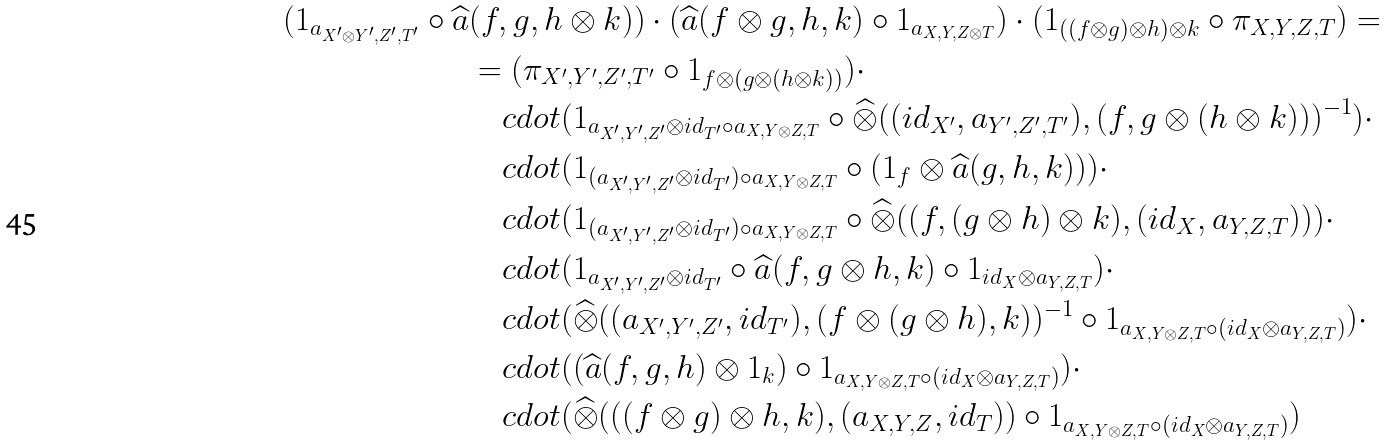<formula> <loc_0><loc_0><loc_500><loc_500>( 1 _ { a _ { X ^ { \prime } \otimes Y ^ { \prime } , Z ^ { \prime } , T ^ { \prime } } } \circ \widehat { a } & ( f , g , h \otimes k ) ) \cdot ( \widehat { a } ( f \otimes g , h , k ) \circ 1 _ { a _ { X , Y , Z \otimes T } } ) \cdot ( 1 _ { ( ( f \otimes g ) \otimes h ) \otimes k } \circ \pi _ { X , Y , Z , T } ) = \\ & = ( \pi _ { X ^ { \prime } , Y ^ { \prime } , Z ^ { \prime } , T ^ { \prime } } \circ 1 _ { f \otimes ( g \otimes ( h \otimes k ) ) } ) \cdot \\ & \quad c d o t ( 1 _ { a _ { X ^ { \prime } , Y ^ { \prime } , Z ^ { \prime } } \otimes i d _ { T ^ { \prime } } \circ a _ { X , Y \otimes Z , T } } \circ \widehat { \otimes } ( ( i d _ { X ^ { \prime } } , a _ { Y ^ { \prime } , Z ^ { \prime } , T ^ { \prime } } ) , ( f , g \otimes ( h \otimes k ) ) ) ^ { - 1 } ) \cdot \\ & \quad c d o t ( 1 _ { ( a _ { X ^ { \prime } , Y ^ { \prime } , Z ^ { \prime } } \otimes i d _ { T ^ { \prime } } ) \circ a _ { X , Y \otimes Z , T } } \circ ( 1 _ { f } \otimes \widehat { a } ( g , h , k ) ) ) \cdot \\ & \quad c d o t ( 1 _ { ( a _ { X ^ { \prime } , Y ^ { \prime } , Z ^ { \prime } } \otimes i d _ { T ^ { \prime } } ) \circ a _ { X , Y \otimes Z , T } } \circ \widehat { \otimes } ( ( f , ( g \otimes h ) \otimes k ) , ( i d _ { X } , a _ { Y , Z , T } ) ) ) \cdot \\ & \quad c d o t ( 1 _ { a _ { X ^ { \prime } , Y ^ { \prime } , Z ^ { \prime } } \otimes i d _ { T ^ { \prime } } } \circ \widehat { a } ( f , g \otimes h , k ) \circ 1 _ { i d _ { X } \otimes a _ { Y , Z , T } } ) \cdot \\ & \quad c d o t ( \widehat { \otimes } ( ( a _ { X ^ { \prime } , Y ^ { \prime } , Z ^ { \prime } } , i d _ { T ^ { \prime } } ) , ( f \otimes ( g \otimes h ) , k ) ) ^ { - 1 } \circ 1 _ { a _ { X , Y \otimes Z , T } \circ ( i d _ { X } \otimes a _ { Y , Z , T } ) } ) \cdot \\ & \quad c d o t ( ( \widehat { a } ( f , g , h ) \otimes 1 _ { k } ) \circ 1 _ { a _ { X , Y \otimes Z , T } \circ ( i d _ { X } \otimes a _ { Y , Z , T } ) } ) \cdot \\ & \quad c d o t ( \widehat { \otimes } ( ( ( f \otimes g ) \otimes h , k ) , ( a _ { X , Y , Z } , i d _ { T } ) ) \circ 1 _ { a _ { X , Y \otimes Z , T } \circ ( i d _ { X } \otimes a _ { Y , Z , T } ) } )</formula> 